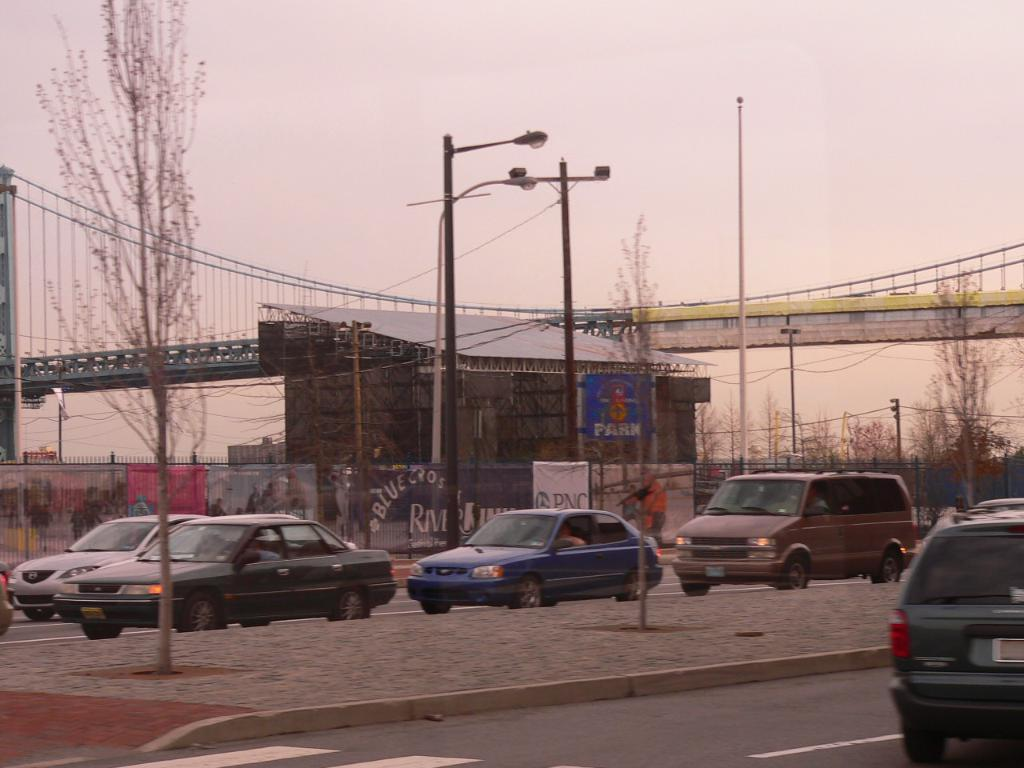What is happening on the road in the image? Cars are passing on the road in the image. What can be seen in the background of the image? There are utility poles, a lamppost, and a bridge in the background of the image. Where is the store selling coal in the image? There is no store selling coal present in the image. How does the lamppost grip the road in the image? The lamppost does not grip the road; it is stationary and upright in the image. 